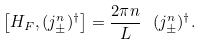Convert formula to latex. <formula><loc_0><loc_0><loc_500><loc_500>\left [ H _ { F } , ( j _ { \pm } ^ { n } ) ^ { \dagger } \right ] = \frac { 2 \pi n } { L } \ ( j _ { \pm } ^ { n } ) ^ { \dagger } .</formula> 